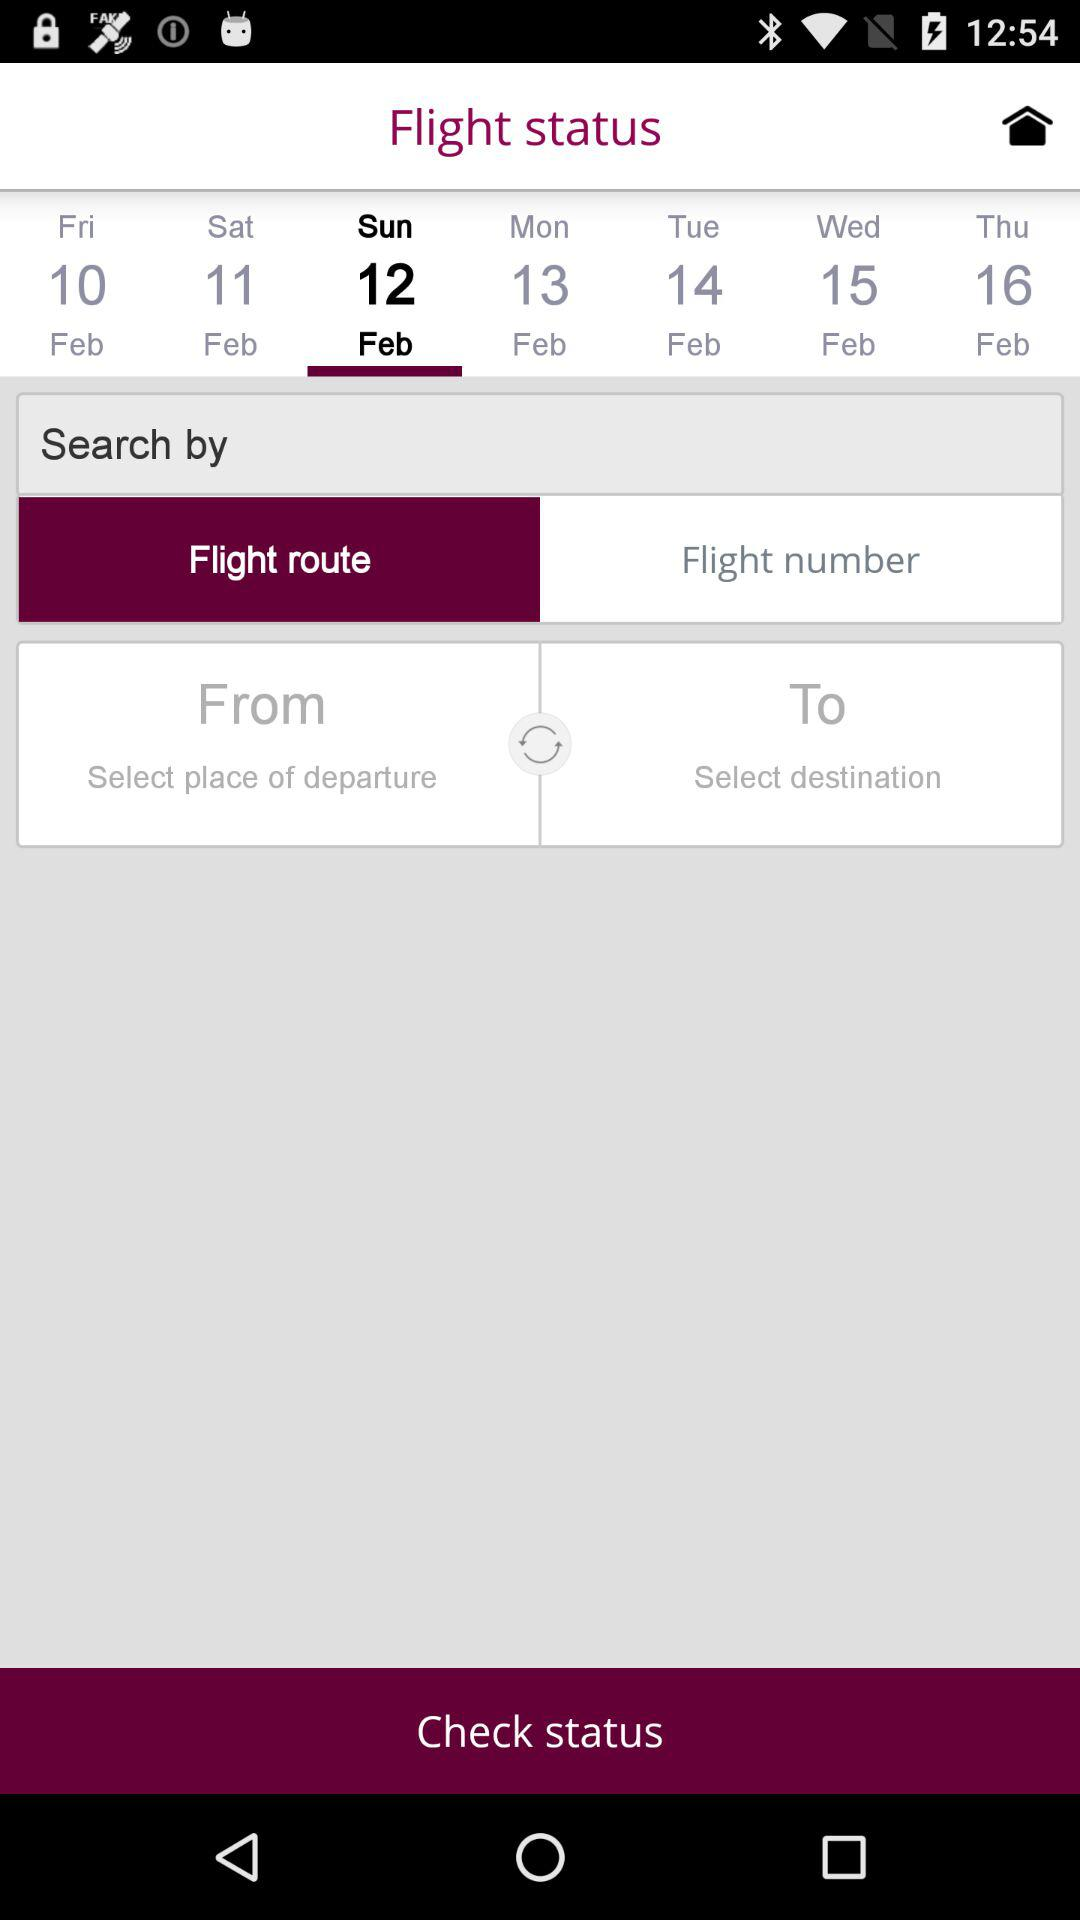Which day falls on the 12th of February? The day is Sunday. 